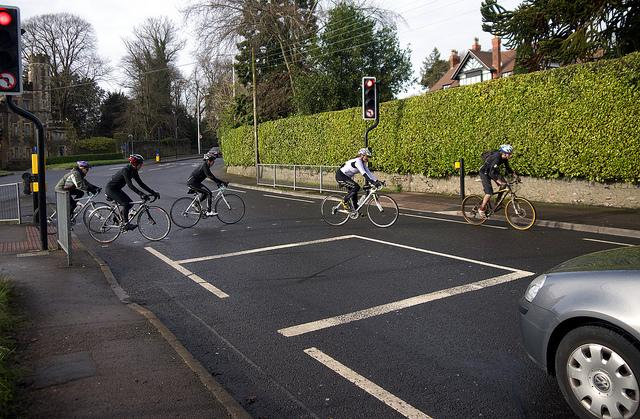If you're in a car coming from this way what is forbidden? turning left 